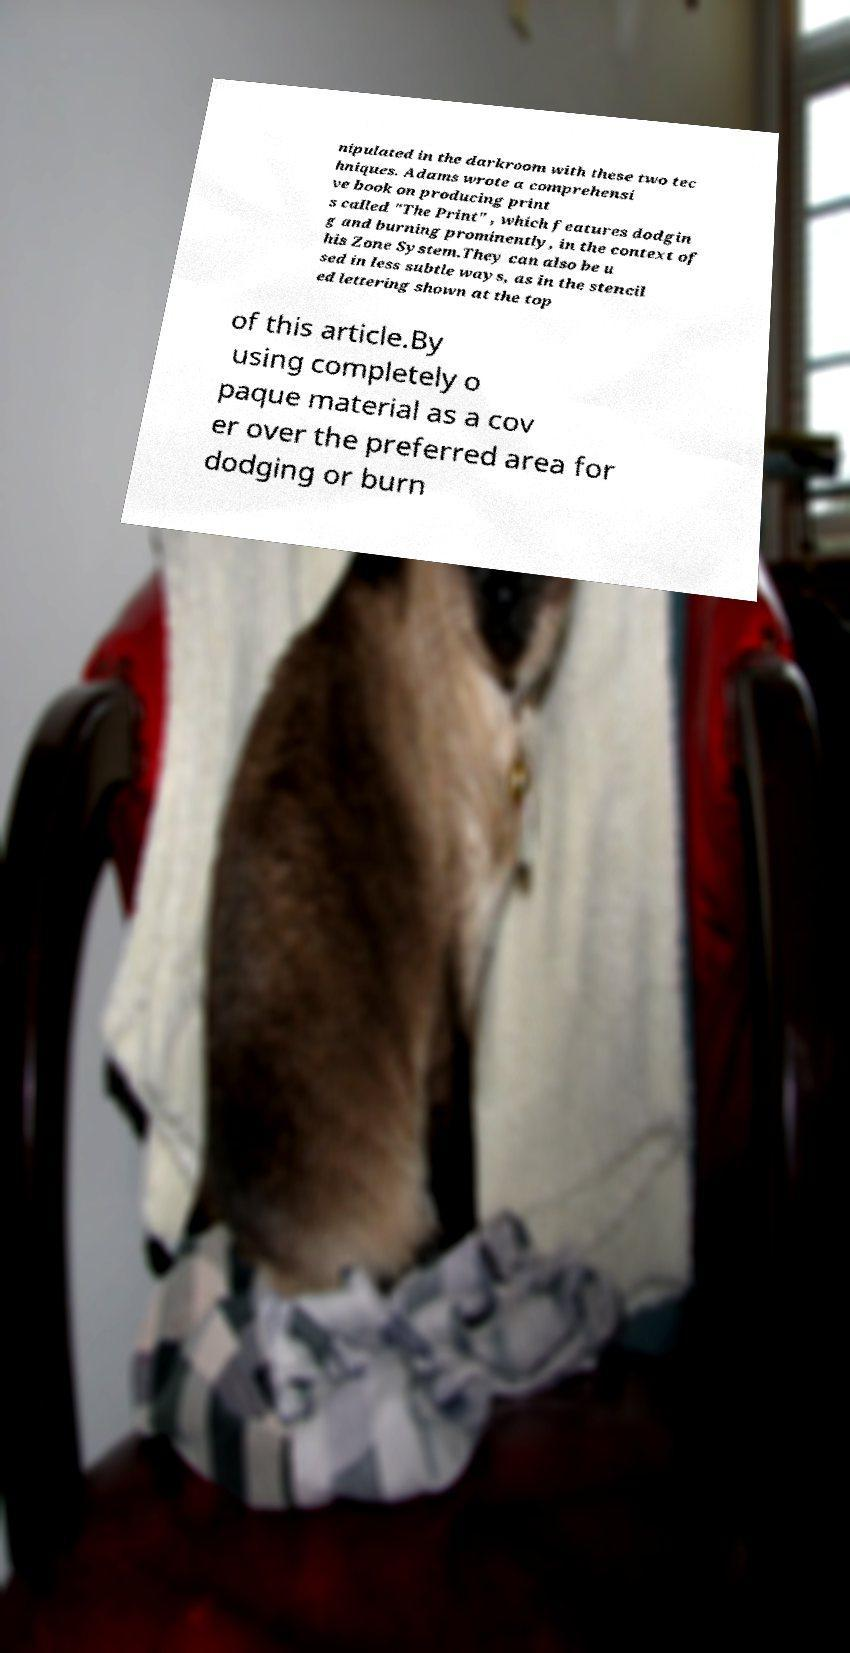Could you assist in decoding the text presented in this image and type it out clearly? nipulated in the darkroom with these two tec hniques. Adams wrote a comprehensi ve book on producing print s called "The Print" , which features dodgin g and burning prominently, in the context of his Zone System.They can also be u sed in less subtle ways, as in the stencil ed lettering shown at the top of this article.By using completely o paque material as a cov er over the preferred area for dodging or burn 